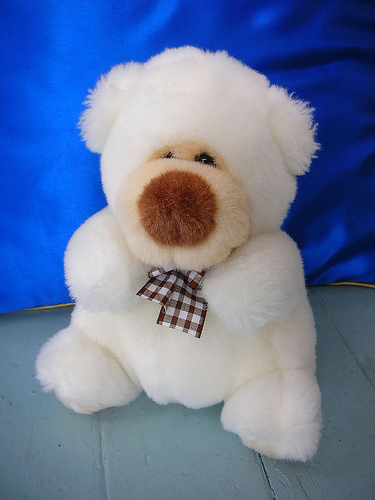<image>
Is there a teddy on the floor? Yes. Looking at the image, I can see the teddy is positioned on top of the floor, with the floor providing support. 